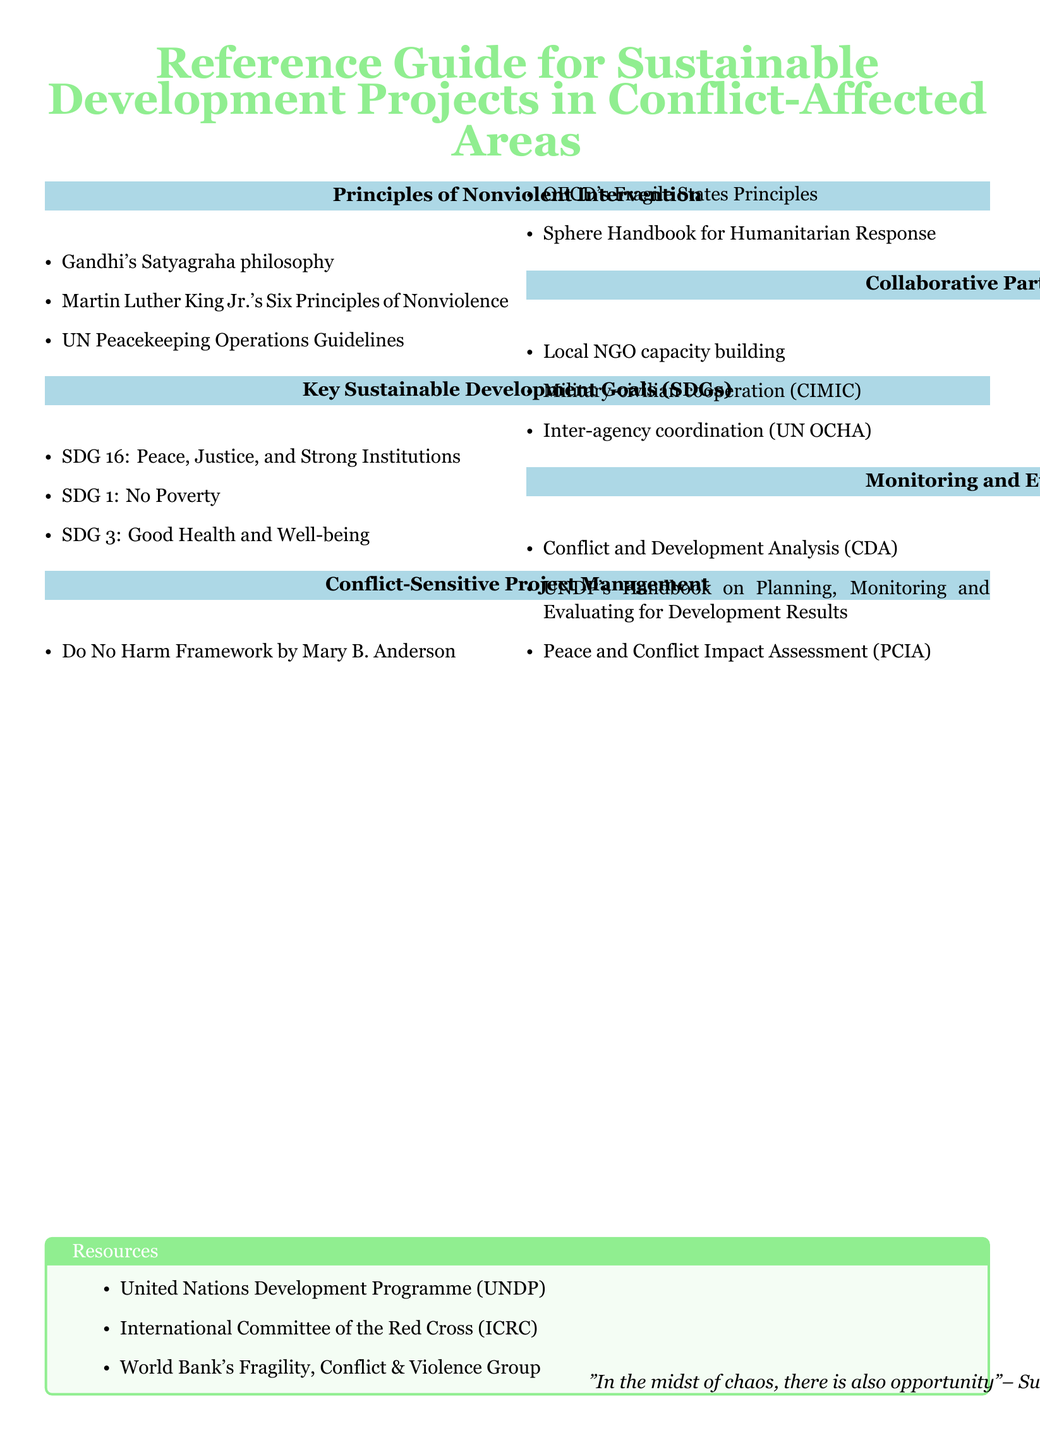What are the three principles of nonviolent intervention mentioned? The principles are listed under the section "Principles of Nonviolent Intervention," which includes references to influential figures and guidelines.
Answer: Gandhi's Satyagraha philosophy, Martin Luther King Jr.'s Six Principles of Nonviolence, UN Peacekeeping Operations Guidelines What is SDG 16 focused on? SDG 16 is highlighted under the "Key Sustainable Development Goals" section, emphasizing its relevance to peace and institutions.
Answer: Peace, Justice, and Strong Institutions What framework is associated with conflict-sensitive project management? The "Conflict-Sensitive Project Management" section mentions specific frameworks guiding project execution in conflict zones.
Answer: Do No Harm Framework by Mary B. Anderson What organization is dedicated to conflict and development analysis? The "Monitoring and Evaluation" section lists various methodologies and handbooks used for assessing projects.
Answer: UNDP's Handbook on Planning, Monitoring and Evaluating for Development Results Which group is mentioned for collaborative partnerships? The "Collaborative Partnerships" section emphasizes the significance of local involvement and coordination for effective project implementation.
Answer: Local NGO capacity building What color is used in the section titles? The color scheme for the document specifically includes color coding for various sections that enhance visual appeal.
Answer: Peaceful blue 